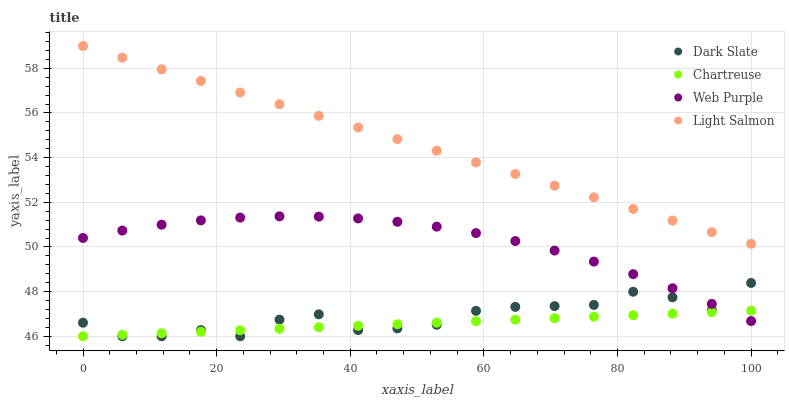Does Chartreuse have the minimum area under the curve?
Answer yes or no. Yes. Does Light Salmon have the maximum area under the curve?
Answer yes or no. Yes. Does Web Purple have the minimum area under the curve?
Answer yes or no. No. Does Web Purple have the maximum area under the curve?
Answer yes or no. No. Is Light Salmon the smoothest?
Answer yes or no. Yes. Is Dark Slate the roughest?
Answer yes or no. Yes. Is Chartreuse the smoothest?
Answer yes or no. No. Is Chartreuse the roughest?
Answer yes or no. No. Does Dark Slate have the lowest value?
Answer yes or no. Yes. Does Web Purple have the lowest value?
Answer yes or no. No. Does Light Salmon have the highest value?
Answer yes or no. Yes. Does Web Purple have the highest value?
Answer yes or no. No. Is Chartreuse less than Light Salmon?
Answer yes or no. Yes. Is Light Salmon greater than Dark Slate?
Answer yes or no. Yes. Does Dark Slate intersect Web Purple?
Answer yes or no. Yes. Is Dark Slate less than Web Purple?
Answer yes or no. No. Is Dark Slate greater than Web Purple?
Answer yes or no. No. Does Chartreuse intersect Light Salmon?
Answer yes or no. No. 